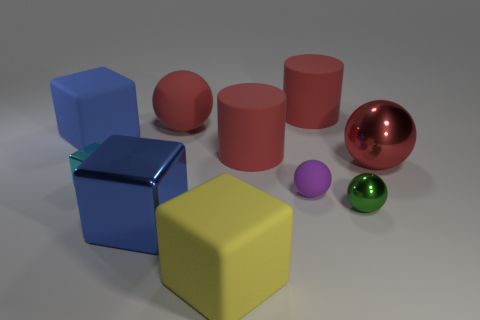Is there anything else that has the same shape as the blue matte thing?
Your answer should be compact. Yes. What is the shape of the tiny cyan shiny thing?
Offer a very short reply. Cube. There is a large rubber object in front of the purple rubber object; is it the same shape as the small purple matte thing?
Provide a short and direct response. No. Are there more small matte balls that are left of the purple rubber object than large objects that are behind the tiny green metal sphere?
Provide a short and direct response. No. How many other things are the same size as the purple ball?
Provide a short and direct response. 2. There is a tiny green thing; does it have the same shape as the big metallic object that is behind the purple matte ball?
Make the answer very short. Yes. What number of rubber objects are either tiny objects or cylinders?
Keep it short and to the point. 3. Are there any small metallic spheres of the same color as the big rubber sphere?
Keep it short and to the point. No. Are there any tiny green metallic objects?
Give a very brief answer. Yes. Do the cyan metal object and the small green metallic thing have the same shape?
Provide a short and direct response. No. 